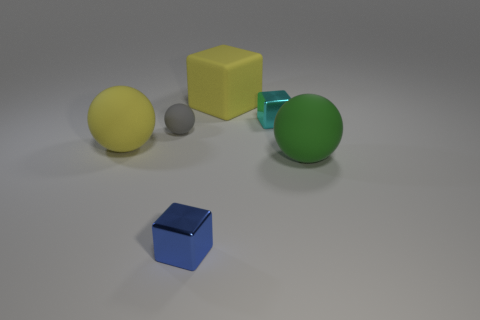Subtract 1 cubes. How many cubes are left? 2 Add 3 large cyan blocks. How many objects exist? 9 Add 6 big green rubber objects. How many big green rubber objects are left? 7 Add 6 big yellow balls. How many big yellow balls exist? 7 Subtract 0 brown spheres. How many objects are left? 6 Subtract all yellow matte spheres. Subtract all tiny blue metallic blocks. How many objects are left? 4 